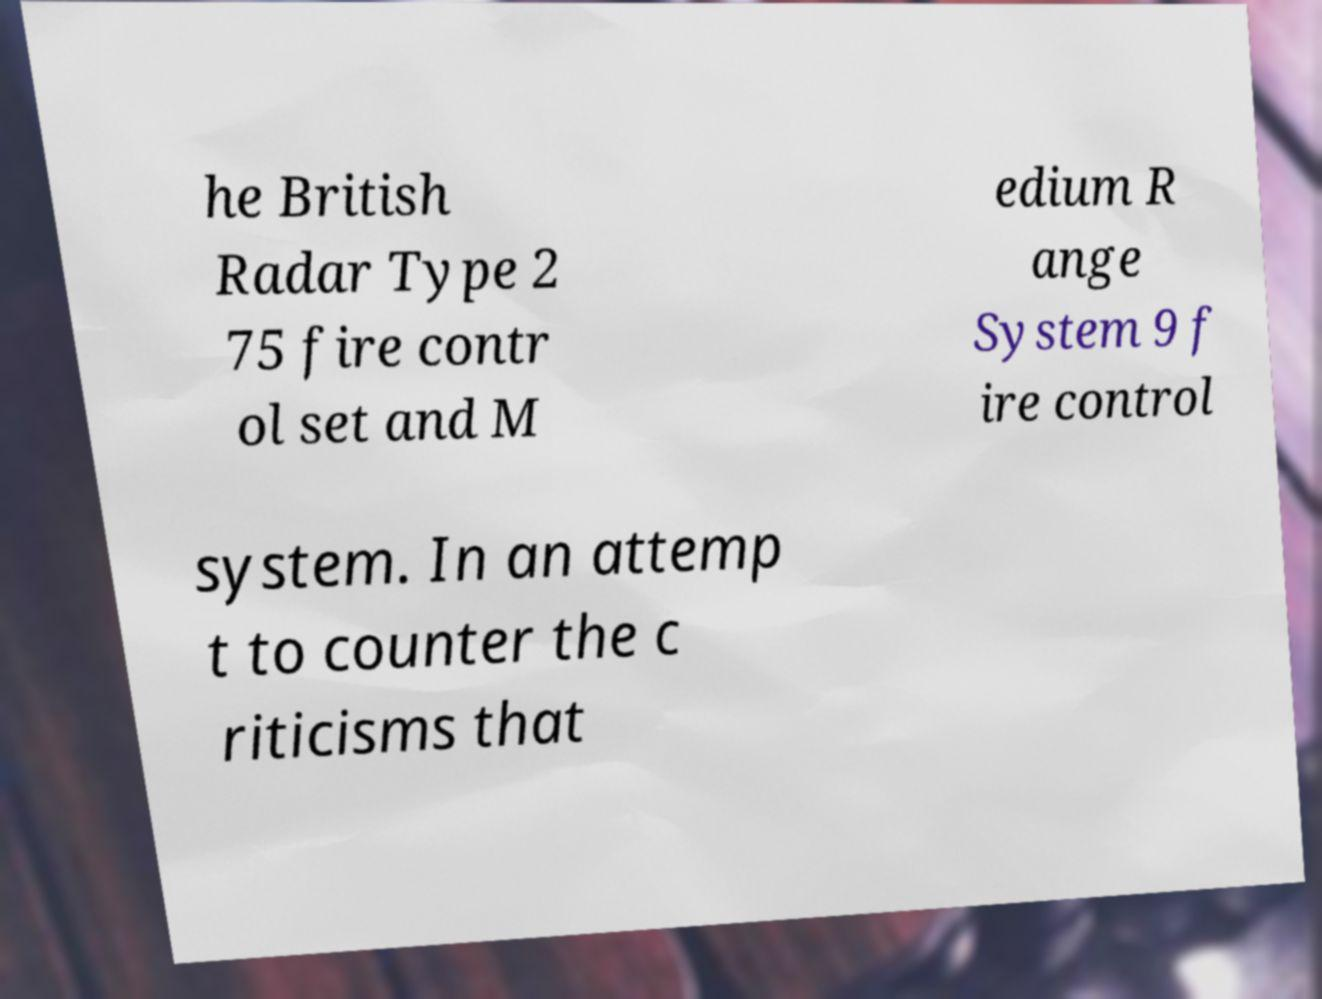There's text embedded in this image that I need extracted. Can you transcribe it verbatim? he British Radar Type 2 75 fire contr ol set and M edium R ange System 9 f ire control system. In an attemp t to counter the c riticisms that 